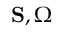Convert formula to latex. <formula><loc_0><loc_0><loc_500><loc_500>{ S } , { \Omega }</formula> 